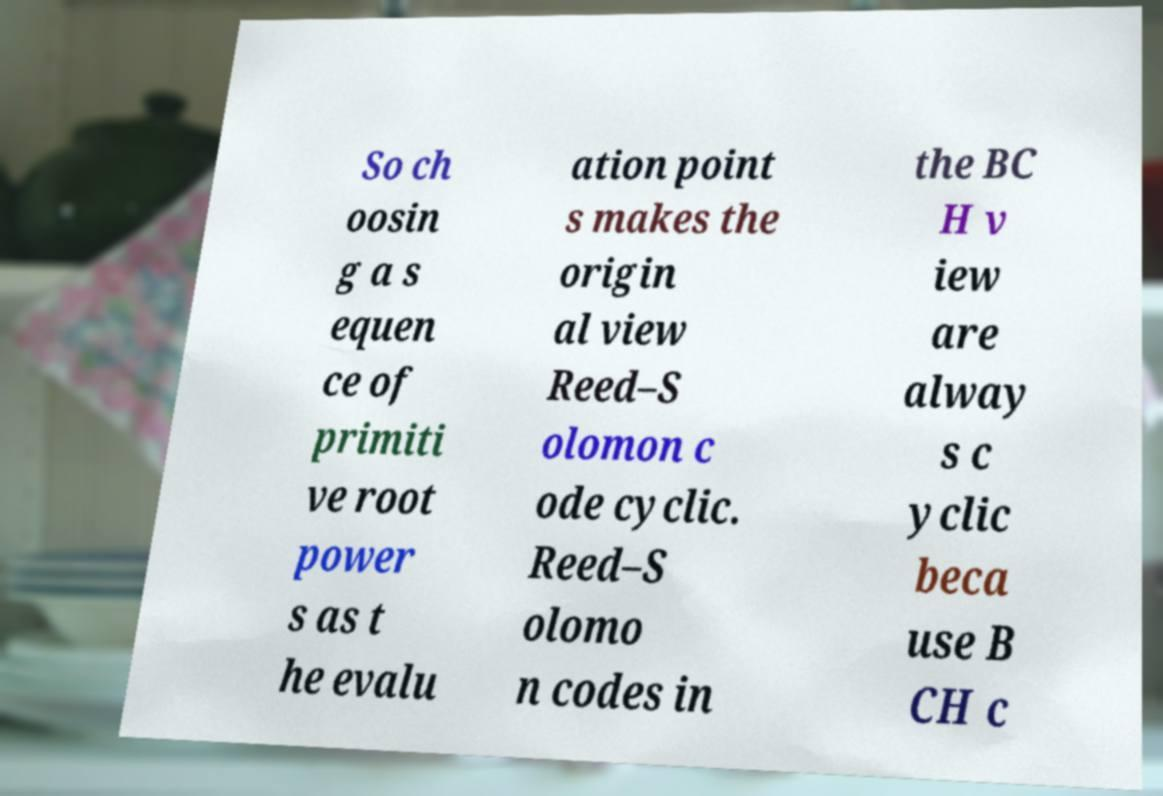Could you assist in decoding the text presented in this image and type it out clearly? So ch oosin g a s equen ce of primiti ve root power s as t he evalu ation point s makes the origin al view Reed–S olomon c ode cyclic. Reed–S olomo n codes in the BC H v iew are alway s c yclic beca use B CH c 